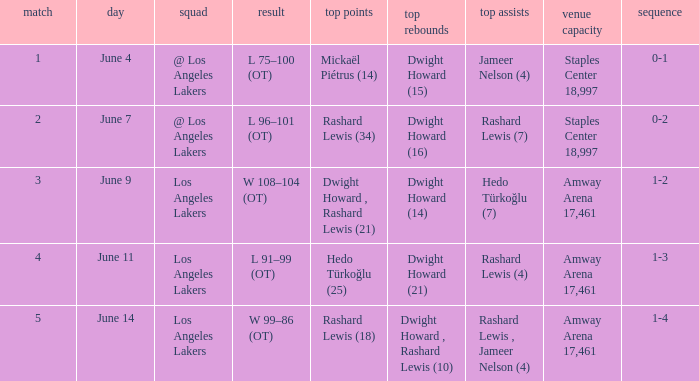What is Team, when High Assists is "Rashard Lewis (4)"? Los Angeles Lakers. 